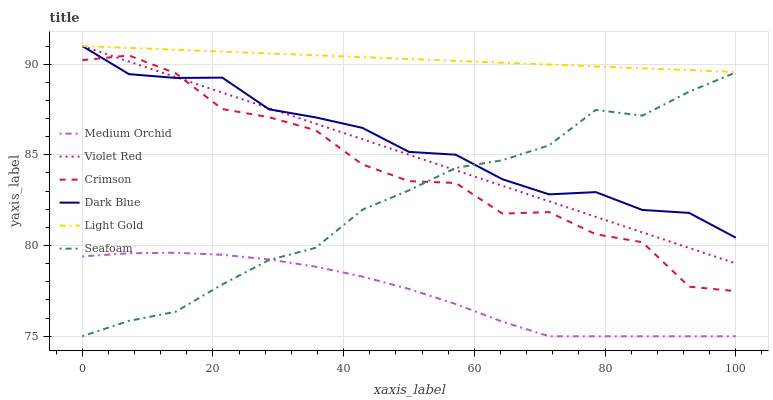Does Medium Orchid have the minimum area under the curve?
Answer yes or no. Yes. Does Light Gold have the maximum area under the curve?
Answer yes or no. Yes. Does Seafoam have the minimum area under the curve?
Answer yes or no. No. Does Seafoam have the maximum area under the curve?
Answer yes or no. No. Is Light Gold the smoothest?
Answer yes or no. Yes. Is Crimson the roughest?
Answer yes or no. Yes. Is Medium Orchid the smoothest?
Answer yes or no. No. Is Medium Orchid the roughest?
Answer yes or no. No. Does Medium Orchid have the lowest value?
Answer yes or no. Yes. Does Dark Blue have the lowest value?
Answer yes or no. No. Does Light Gold have the highest value?
Answer yes or no. Yes. Does Seafoam have the highest value?
Answer yes or no. No. Is Medium Orchid less than Violet Red?
Answer yes or no. Yes. Is Crimson greater than Medium Orchid?
Answer yes or no. Yes. Does Seafoam intersect Dark Blue?
Answer yes or no. Yes. Is Seafoam less than Dark Blue?
Answer yes or no. No. Is Seafoam greater than Dark Blue?
Answer yes or no. No. Does Medium Orchid intersect Violet Red?
Answer yes or no. No. 